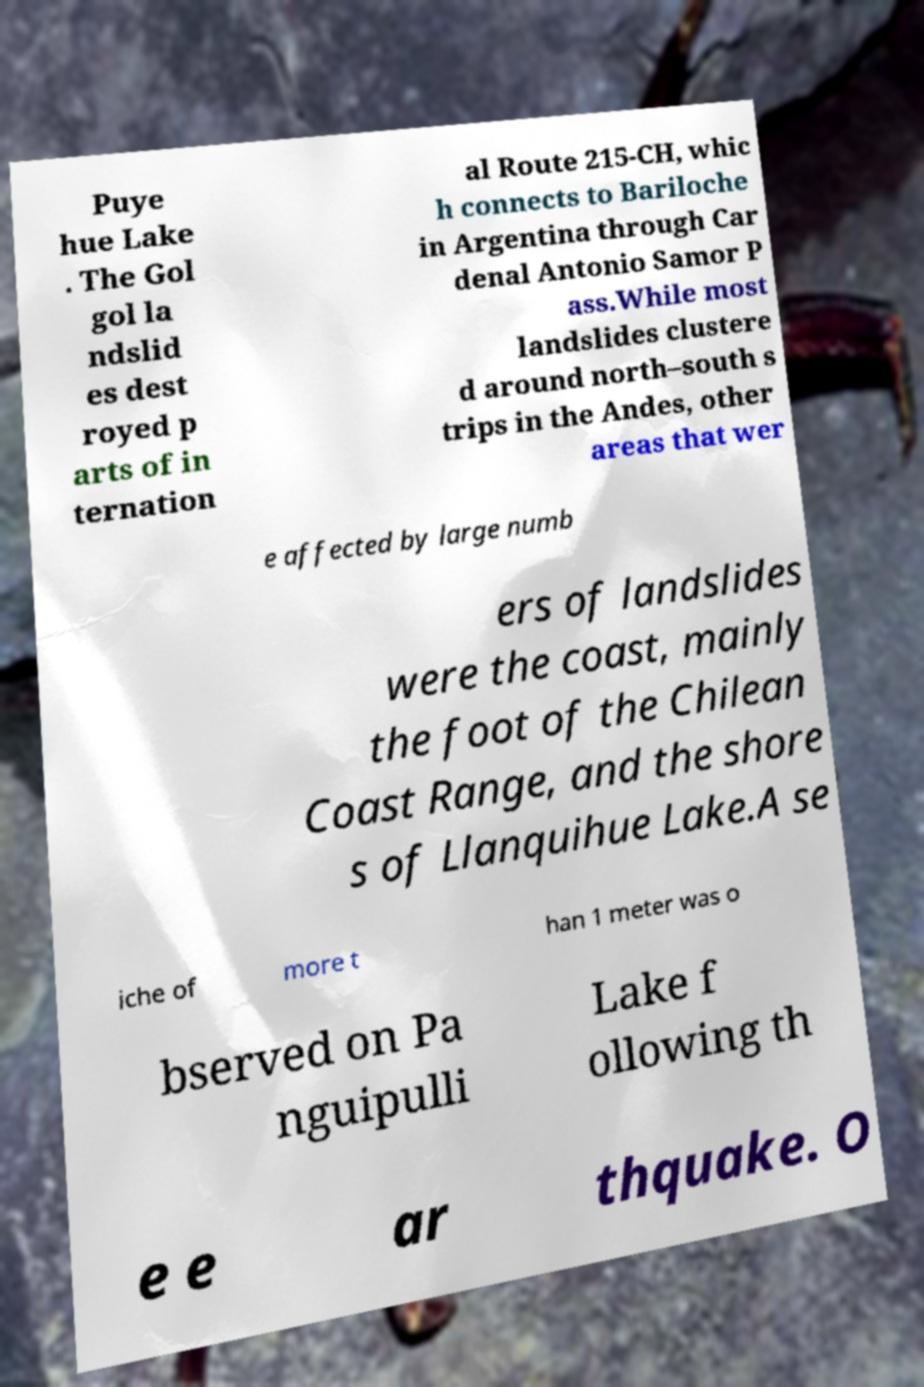Please read and relay the text visible in this image. What does it say? Puye hue Lake . The Gol gol la ndslid es dest royed p arts of in ternation al Route 215-CH, whic h connects to Bariloche in Argentina through Car denal Antonio Samor P ass.While most landslides clustere d around north–south s trips in the Andes, other areas that wer e affected by large numb ers of landslides were the coast, mainly the foot of the Chilean Coast Range, and the shore s of Llanquihue Lake.A se iche of more t han 1 meter was o bserved on Pa nguipulli Lake f ollowing th e e ar thquake. O 